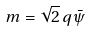Convert formula to latex. <formula><loc_0><loc_0><loc_500><loc_500>m = \sqrt { 2 } \, q \bar { \psi }</formula> 